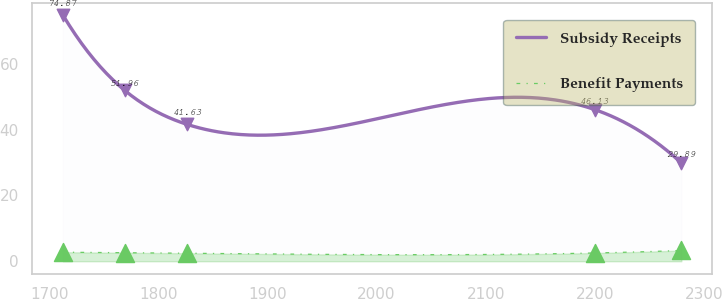<chart> <loc_0><loc_0><loc_500><loc_500><line_chart><ecel><fcel>Subsidy Receipts<fcel>Benefit Payments<nl><fcel>1712.66<fcel>74.87<fcel>2.75<nl><fcel>1769.32<fcel>51.96<fcel>2.59<nl><fcel>1826.41<fcel>41.63<fcel>2.43<nl><fcel>2199.9<fcel>46.13<fcel>2.51<nl><fcel>2279.24<fcel>29.89<fcel>3.27<nl></chart> 